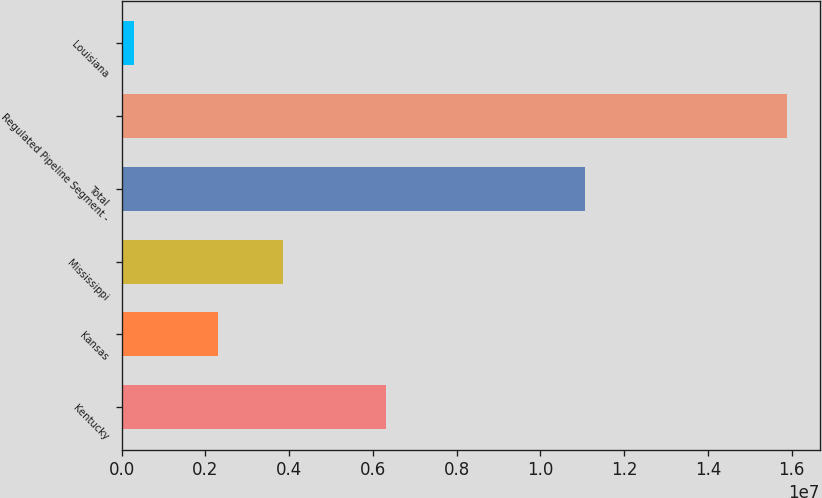Convert chart to OTSL. <chart><loc_0><loc_0><loc_500><loc_500><bar_chart><fcel>Kentucky<fcel>Kansas<fcel>Mississippi<fcel>Total<fcel>Regulated Pipeline Segment -<fcel>Louisiana<nl><fcel>6.32228e+06<fcel>2.3e+06<fcel>3.85771e+06<fcel>1.10652e+07<fcel>1.5878e+07<fcel>300973<nl></chart> 